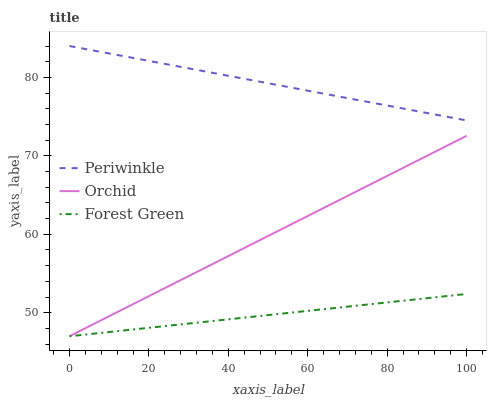Does Forest Green have the minimum area under the curve?
Answer yes or no. Yes. Does Periwinkle have the maximum area under the curve?
Answer yes or no. Yes. Does Orchid have the minimum area under the curve?
Answer yes or no. No. Does Orchid have the maximum area under the curve?
Answer yes or no. No. Is Forest Green the smoothest?
Answer yes or no. Yes. Is Periwinkle the roughest?
Answer yes or no. Yes. Is Orchid the smoothest?
Answer yes or no. No. Is Orchid the roughest?
Answer yes or no. No. Does Forest Green have the lowest value?
Answer yes or no. Yes. Does Periwinkle have the lowest value?
Answer yes or no. No. Does Periwinkle have the highest value?
Answer yes or no. Yes. Does Orchid have the highest value?
Answer yes or no. No. Is Orchid less than Periwinkle?
Answer yes or no. Yes. Is Periwinkle greater than Orchid?
Answer yes or no. Yes. Does Forest Green intersect Orchid?
Answer yes or no. Yes. Is Forest Green less than Orchid?
Answer yes or no. No. Is Forest Green greater than Orchid?
Answer yes or no. No. Does Orchid intersect Periwinkle?
Answer yes or no. No. 